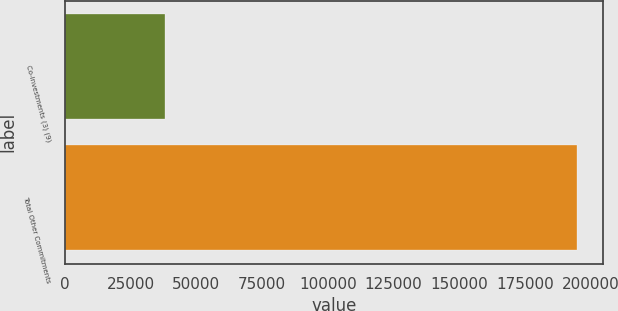<chart> <loc_0><loc_0><loc_500><loc_500><bar_chart><fcel>Co-investments (3) (9)<fcel>Total Other Commitments<nl><fcel>38214<fcel>194885<nl></chart> 